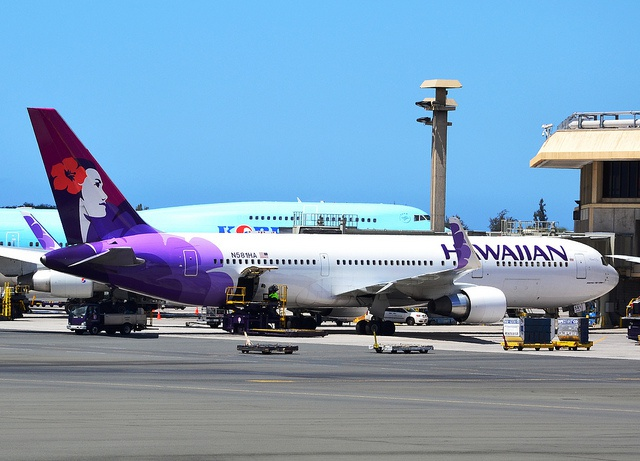Describe the objects in this image and their specific colors. I can see airplane in lightblue, white, black, darkgray, and navy tones, airplane in lightblue and gray tones, truck in lightblue, black, gray, and darkgray tones, car in lightblue, black, gray, white, and darkgray tones, and people in lightblue, black, green, darkgreen, and lime tones in this image. 